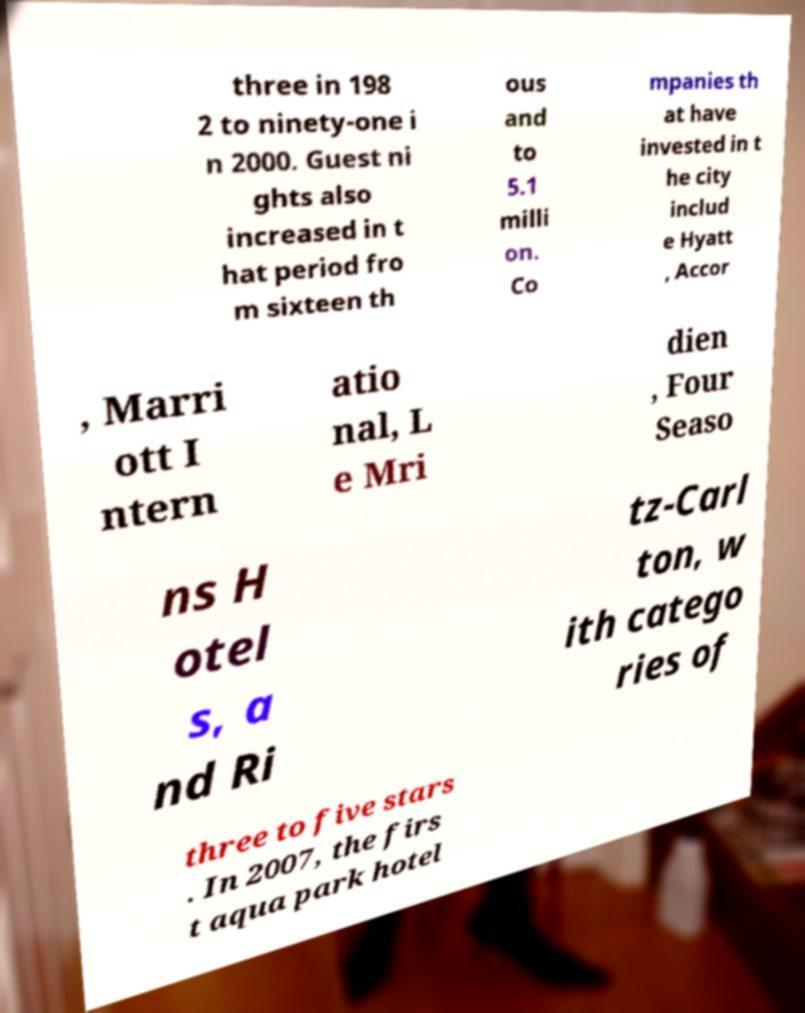Can you accurately transcribe the text from the provided image for me? three in 198 2 to ninety-one i n 2000. Guest ni ghts also increased in t hat period fro m sixteen th ous and to 5.1 milli on. Co mpanies th at have invested in t he city includ e Hyatt , Accor , Marri ott I ntern atio nal, L e Mri dien , Four Seaso ns H otel s, a nd Ri tz-Carl ton, w ith catego ries of three to five stars . In 2007, the firs t aqua park hotel 